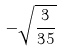Convert formula to latex. <formula><loc_0><loc_0><loc_500><loc_500>- \sqrt { \frac { 3 } { 3 5 } }</formula> 